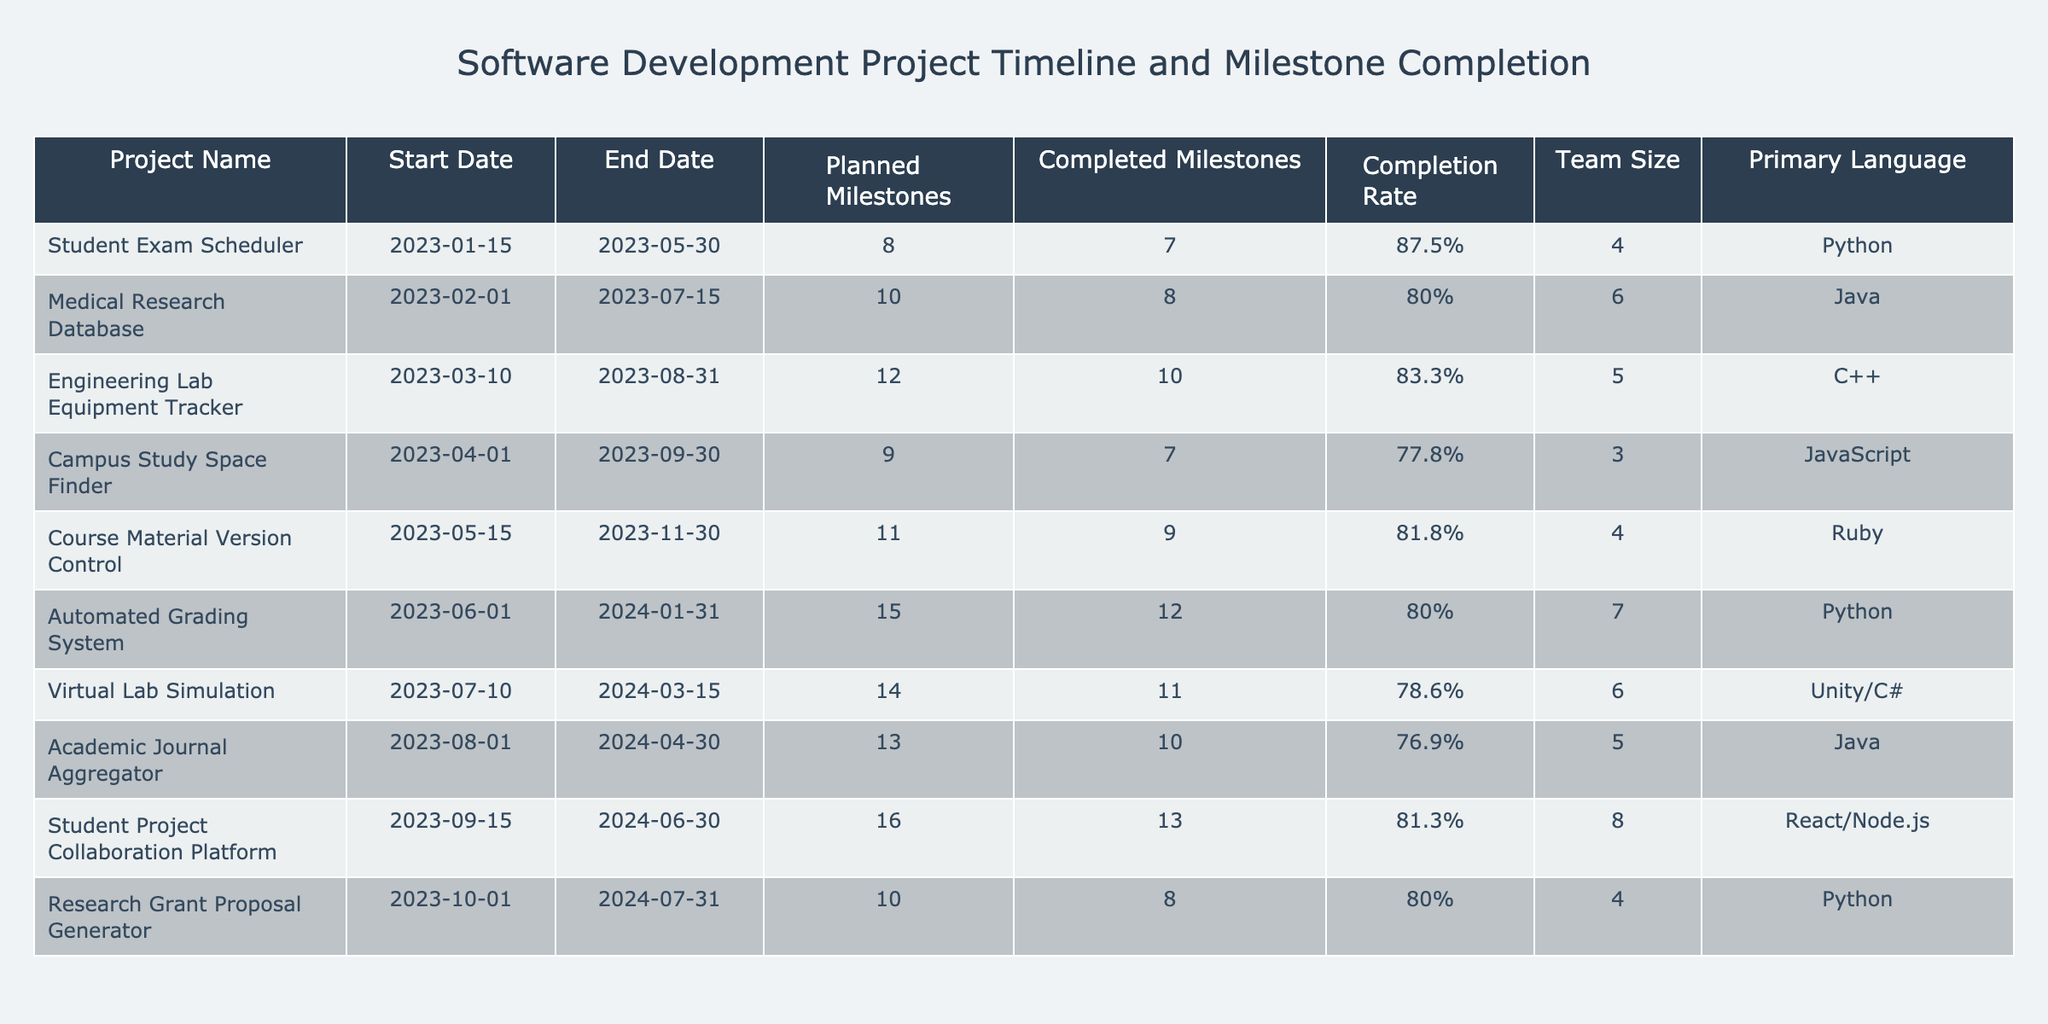What is the completion rate of the Engineering Lab Equipment Tracker project? The completion rate is directly stated in the table under the "Completion Rate" column for the Engineering Lab Equipment Tracker project. It shows 83.3%.
Answer: 83.3% How many planned milestones does the Automated Grading System have? The planned milestones for the Automated Grading System can be found in the "Planned Milestones" column. It indicates that there are 15 planned milestones.
Answer: 15 Which project has the highest number of completed milestones? By examining the "Completed Milestones" column, we find that the Student Project Collaboration Platform has the highest number of completed milestones at 13.
Answer: 13 What is the average completion rate of projects using Python? The completion rates for Python projects are 87.5% (Student Exam Scheduler), 80% (Automated Grading System), and 80% (Research Grant Proposal Generator). Adding these gives 247.5%, and dividing by 3 gives an average of 82.5%.
Answer: 82.5% Is the Campus Study Space Finder project's completion rate higher than 80%? Checking the "Completion Rate" column reveals that the Campus Study Space Finder's completion rate is 77.8%, which is lower than 80%.
Answer: No What is the difference in completion rates between the Medical Research Database and the Course Material Version Control projects? The completion rate for the Medical Research Database is 80%, and for the Course Material Version Control, it is 81.8%. The difference is calculated as 81.8% - 80% = 1.8%.
Answer: 1.8% Which programming language has the highest team size, and what is that size? By looking at the "Team Size" column, the Automated Grading System has the highest team size of 7.
Answer: 7 Which project has the longest duration? The duration is found by checking the "Start Date" and "End Date" columns. The project with the longest duration is the Automated Grading System (2023-06-01 to 2024-01-31), which is 8 months and 30 days.
Answer: Automated Grading System Which project has more planned milestones: the Academic Journal Aggregator or the Campus Study Space Finder? Referring to the "Planned Milestones" column, the Academic Journal Aggregator has 13 planned milestones, while the Campus Study Space Finder has 9. Thus, the Academic Journal Aggregator has more.
Answer: Academic Journal Aggregator What percentage of projects completed at least 80% of their milestones? The projects that completed at least 80% are: Student Exam Scheduler (87.5%), Medical Research Database (80%), Engineering Lab Equipment Tracker (83.3%), Automated Grading System (80%), Student Project Collaboration Platform (81.3%), and Research Grant Proposal Generator (80%). There are 6 such projects out of a total of 10, which yields (6/10)*100 = 60%.
Answer: 60% 